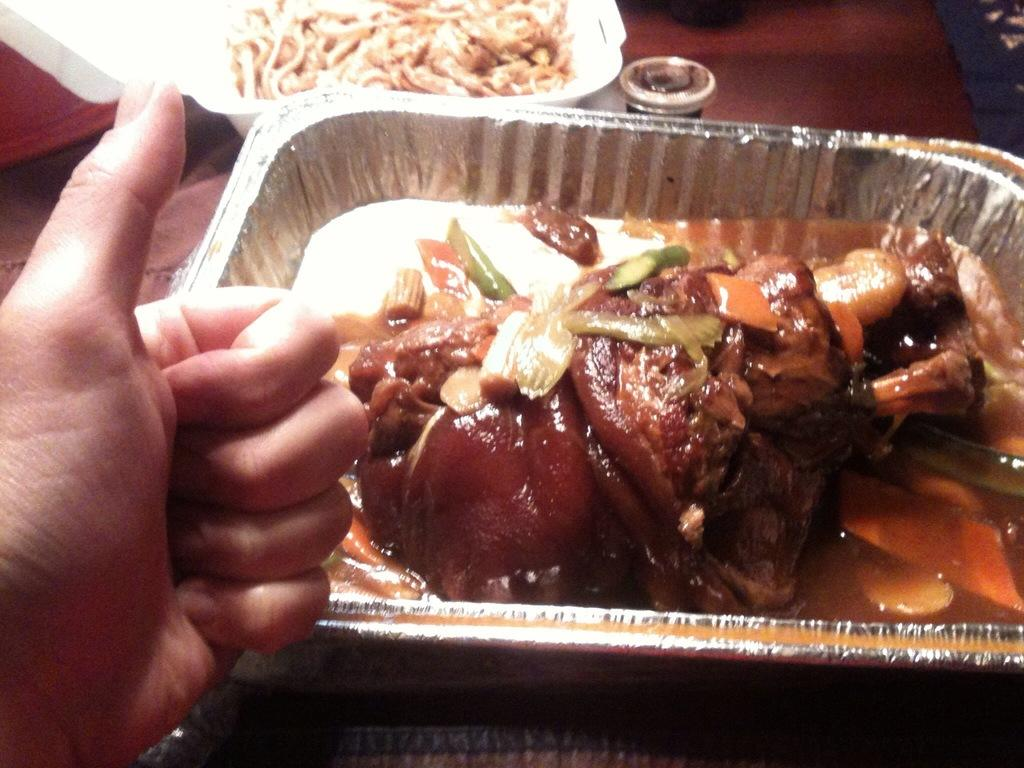What type of container is holding the food in the image? The food is in an aluminium foil container in the image. Where is the container with food located? The container with food is placed on a table top. Can you describe anything else in the image besides the food and container? There is a hand in the left corner of the image. What type of leaf is being held by the goat in the image? There is no goat or leaf present in the image. 